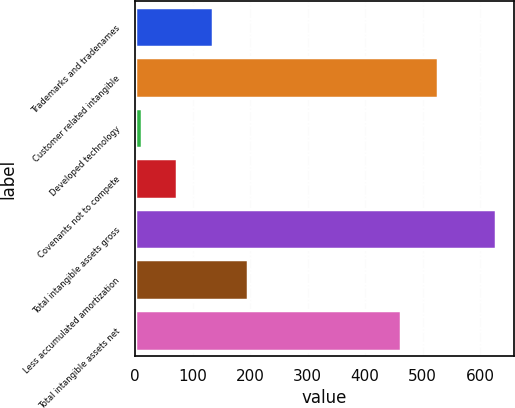Convert chart to OTSL. <chart><loc_0><loc_0><loc_500><loc_500><bar_chart><fcel>Trademarks and tradenames<fcel>Customer related intangible<fcel>Developed technology<fcel>Covenants not to compete<fcel>Total intangible assets gross<fcel>Less accumulated amortization<fcel>Total intangible assets net<nl><fcel>135<fcel>526<fcel>12<fcel>73.5<fcel>627<fcel>196.5<fcel>463<nl></chart> 